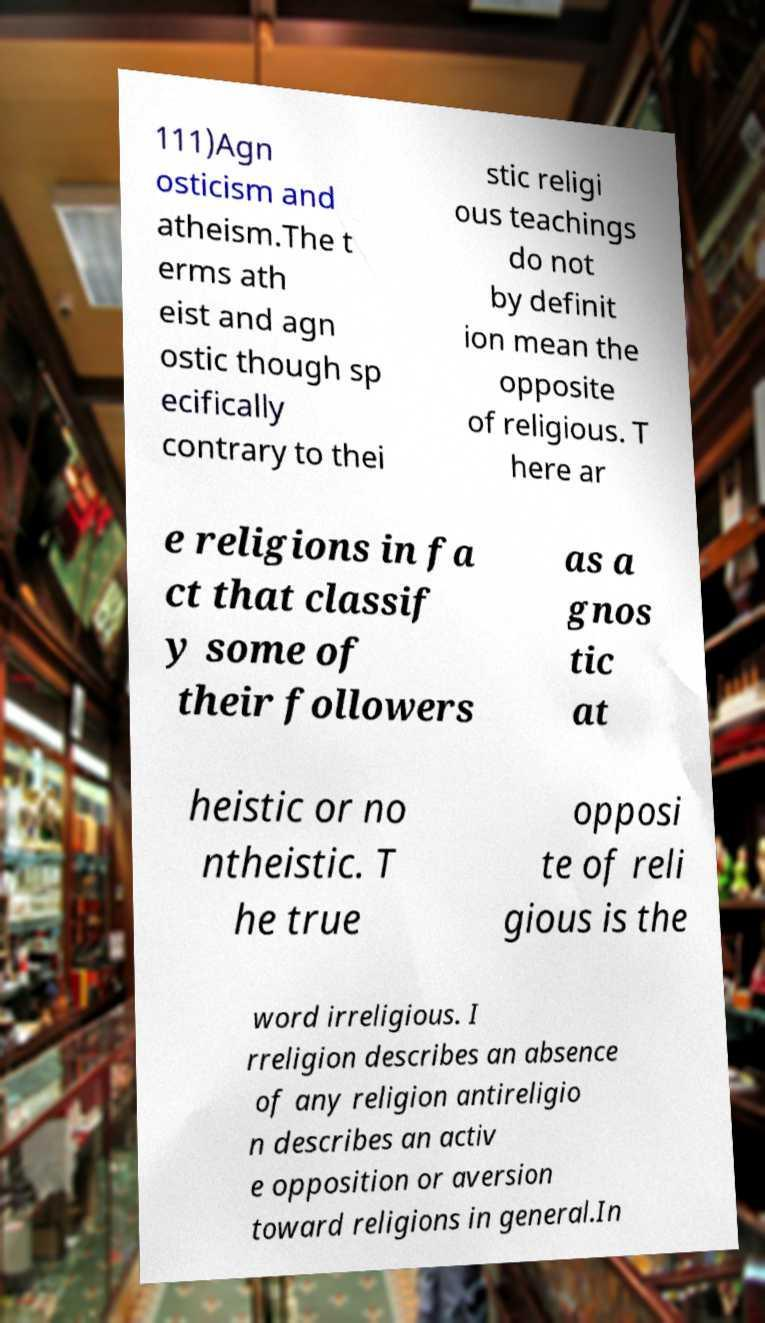For documentation purposes, I need the text within this image transcribed. Could you provide that? 111)Agn osticism and atheism.The t erms ath eist and agn ostic though sp ecifically contrary to thei stic religi ous teachings do not by definit ion mean the opposite of religious. T here ar e religions in fa ct that classif y some of their followers as a gnos tic at heistic or no ntheistic. T he true opposi te of reli gious is the word irreligious. I rreligion describes an absence of any religion antireligio n describes an activ e opposition or aversion toward religions in general.In 